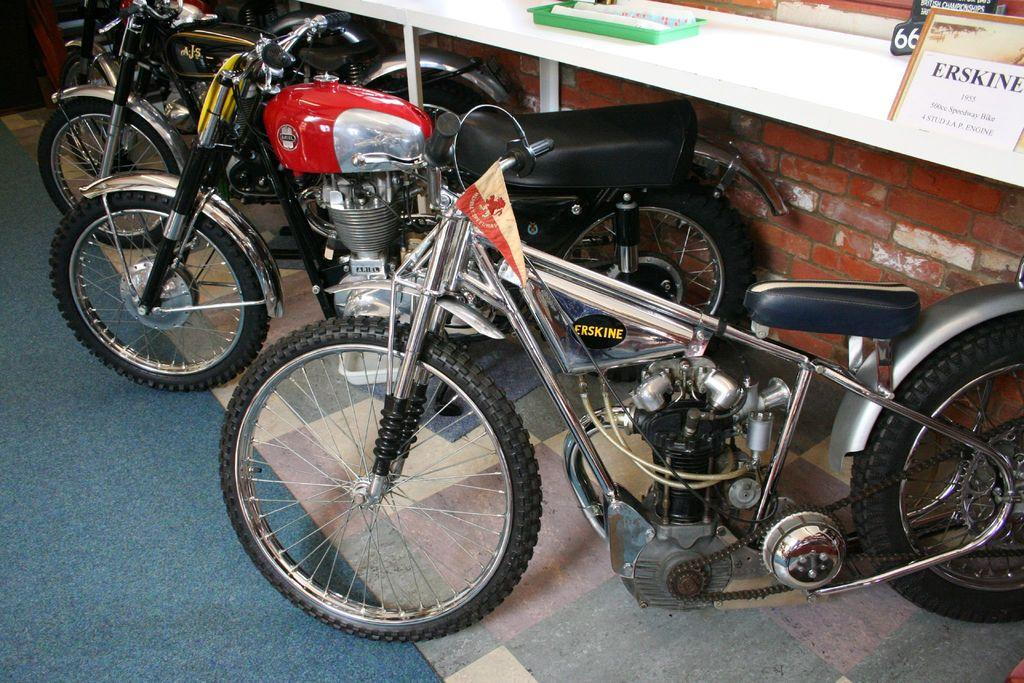What type of vehicles are parked in the image? There are motorcycles parked in the image. What is on the board in the image? There is a paper on a board in the image. What is on the table in the image? There is a tray on a table in the image. What is covering the floor in the image? There is a carpet on the floor in the image. How many cameras are visible on the table in the image? There are no cameras visible on the table in the image. Can you describe the table in the image? The table is not the main focus of the image, but it is mentioned that there is a tray on a table in the image. 